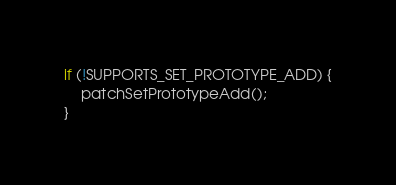Convert code to text. <code><loc_0><loc_0><loc_500><loc_500><_TypeScript_>
if (!SUPPORTS_SET_PROTOTYPE_ADD) {
	patchSetPrototypeAdd();
}
</code> 